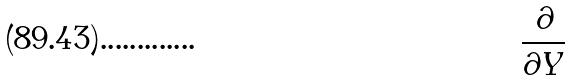Convert formula to latex. <formula><loc_0><loc_0><loc_500><loc_500>\frac { \partial } { \partial Y }</formula> 